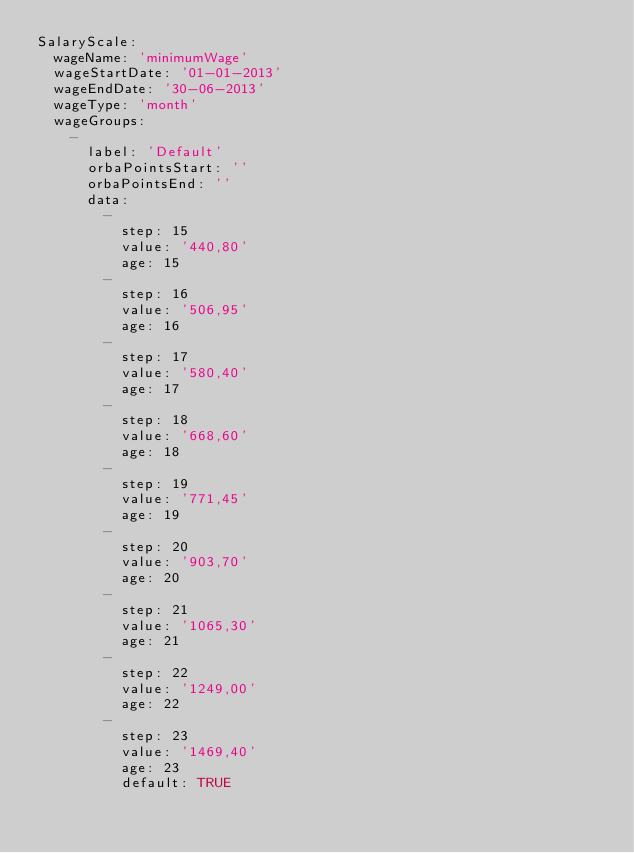Convert code to text. <code><loc_0><loc_0><loc_500><loc_500><_YAML_>SalaryScale:
  wageName: 'minimumWage'
  wageStartDate: '01-01-2013'
  wageEndDate: '30-06-2013'
  wageType: 'month'
  wageGroups:
    -
      label: 'Default'
      orbaPointsStart: ''
      orbaPointsEnd: ''
      data:
        -
          step: 15
          value: '440,80'
          age: 15
        -
          step: 16
          value: '506,95'
          age: 16
        -
          step: 17
          value: '580,40'
          age: 17
        -
          step: 18
          value: '668,60'
          age: 18
        -
          step: 19
          value: '771,45'
          age: 19
        -
          step: 20
          value: '903,70'
          age: 20
        -
          step: 21
          value: '1065,30'
          age: 21
        -
          step: 22
          value: '1249,00'
          age: 22
        -
          step: 23
          value: '1469,40'
          age: 23
          default: TRUE</code> 